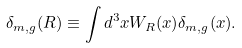<formula> <loc_0><loc_0><loc_500><loc_500>\delta _ { m , g } ( R ) \equiv \int d ^ { 3 } x W _ { R } ( x ) \delta _ { m , g } ( x ) .</formula> 